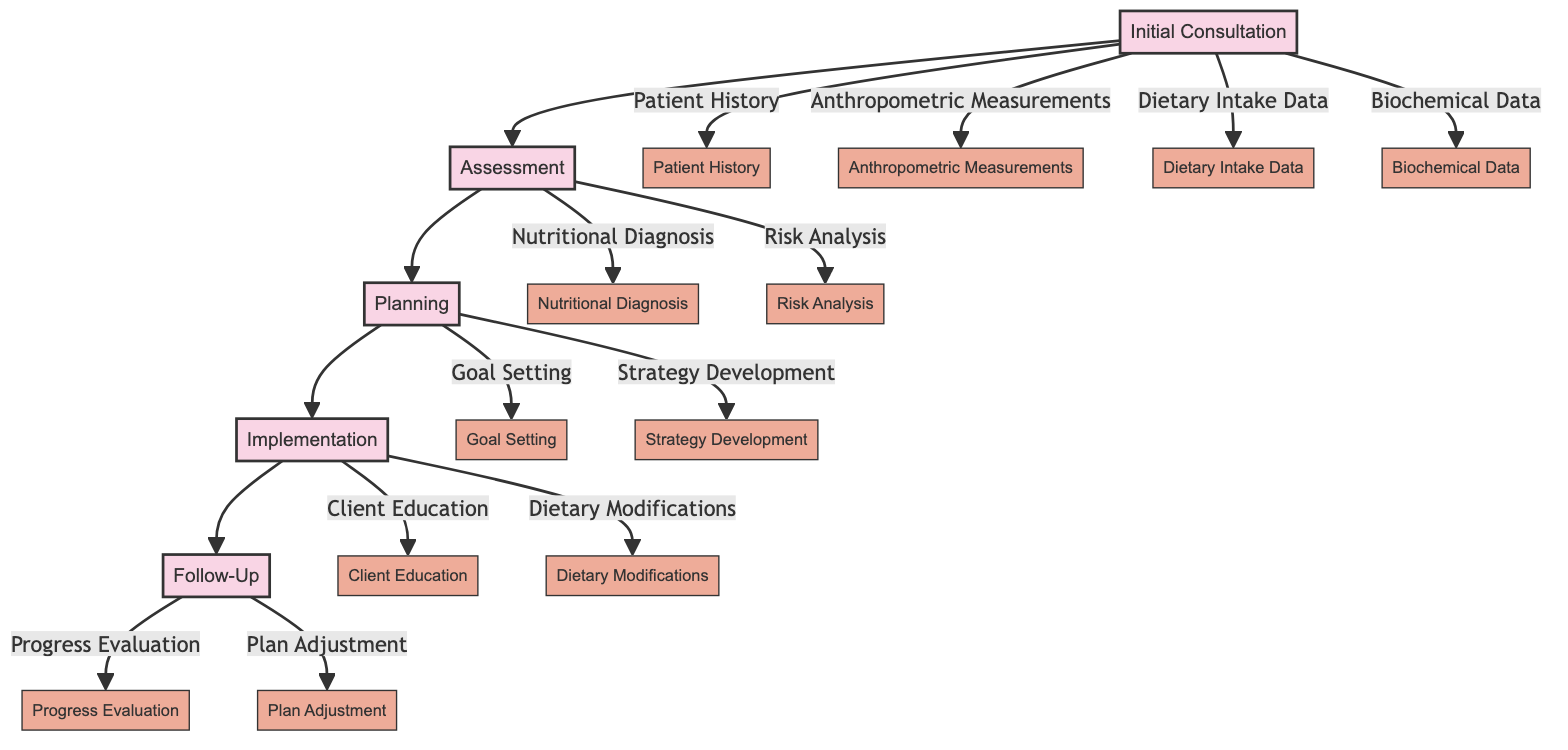What is the first step in the process? The first node in the diagram is "Initial Consultation." It's the starting point of the nutritional assessment process, indicated as the first box in the flowchart.
Answer: Initial Consultation How many main components are there in the nutritional assessment process? The diagram outlines five main components: Initial Consultation, Assessment, Planning, Implementation, and Follow-Up. Counting these provides the answer.
Answer: Five Which node follows "Assessment"? The flow of the diagram shows that "Assessment" connects directly to "Planning," as indicated by the arrow leading from Assessment to Planning.
Answer: Planning What type of data is collected during the "Initial Consultation"? The sub-elements connected to "Initial Consultation" indicate the types of data collected: Patient History, Anthropometric Measurements, Dietary Intake Data, and Biochemical Data.
Answer: Patient History, Anthropometric Measurements, Dietary Intake Data, Biochemical Data What is the purpose of "Follow-Up"? "Follow-Up" is labeled with the purpose of monitoring progress and adjusting the plan, based on the designation of the node as indicated in the diagram.
Answer: Monitor progress and adjust the plan What are the two sub-elements of "Implementation"? The sub-elements under "Implementation" include "Client Education" and "Dietary Modifications," which represent the activities undertaken during that step in the process.
Answer: Client Education, Dietary Modifications What is involved in "Risk Analysis"? "Risk Analysis" is described in the diagram as analyzing potential health risks linked to dietary habits and nutritional status, indicating its focus on assessing risks.
Answer: Analyzing potential health risks Which step comes before "Goal Setting"? The flow before "Goal Setting" indicates that it comes after "Strategy Development," meaning that "Planning" precedes it as part of the process.
Answer: Planning What do you do during "Progress Evaluation"? The node explains that "Progress Evaluation" involves reviewing the client's progress towards goals, indicating an assessment of ongoing achievements in their nutrition plan.
Answer: Review client's progress towards goals 